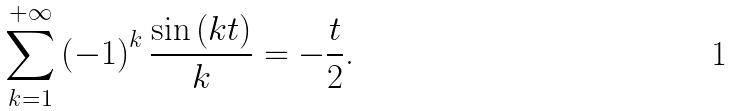<formula> <loc_0><loc_0><loc_500><loc_500>\overset { + \infty } { \underset { k = 1 } { \sum } } \left ( - 1 \right ) ^ { k } \frac { \sin \left ( k t \right ) } { k } = - \frac { t } { 2 } \text {.}</formula> 